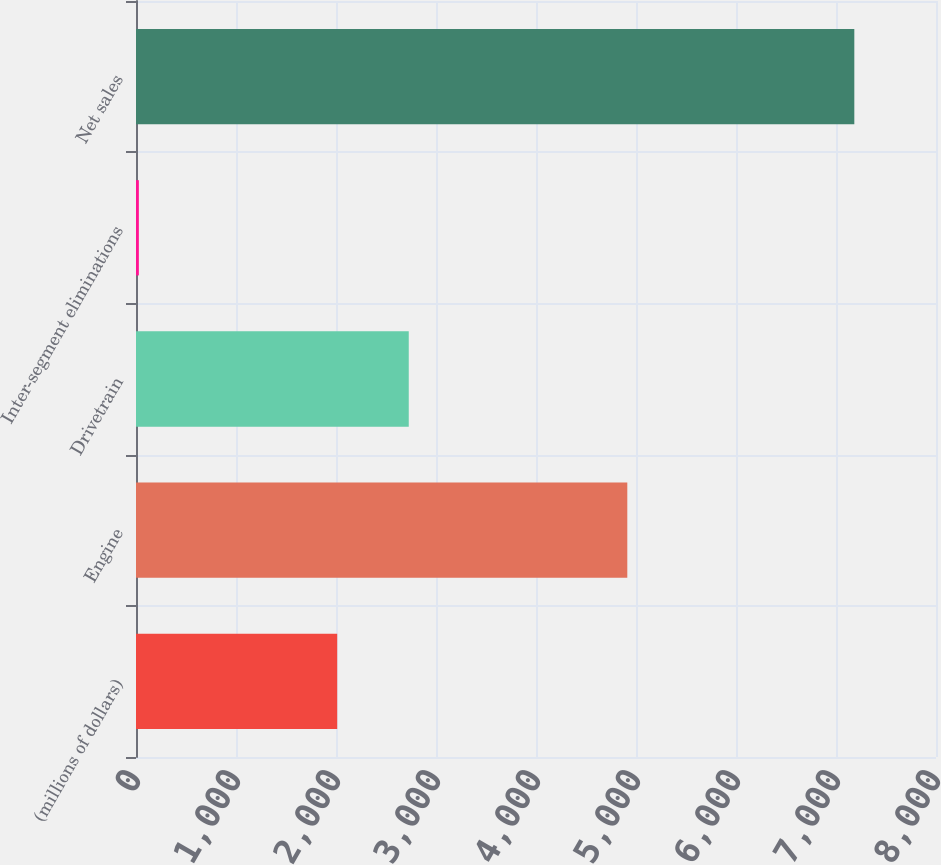<chart> <loc_0><loc_0><loc_500><loc_500><bar_chart><fcel>(millions of dollars)<fcel>Engine<fcel>Drivetrain<fcel>Inter-segment eliminations<fcel>Net sales<nl><fcel>2012<fcel>4913<fcel>2727.47<fcel>28.5<fcel>7183.2<nl></chart> 